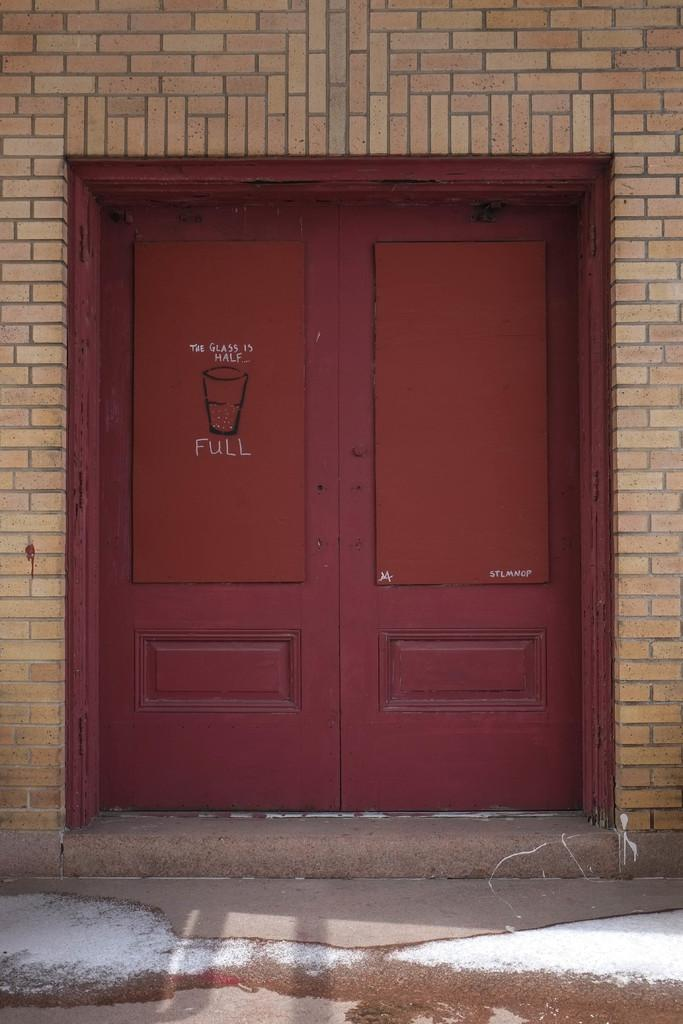What is the main object in the image? There is a door in the image. What color is the door? The door is red in color. What type of material is visible in the background of the image? There is a brick wall in the image. What type of oranges can be seen hanging from the door in the image? There are no oranges present in the image, and therefore no such activity can be observed. 